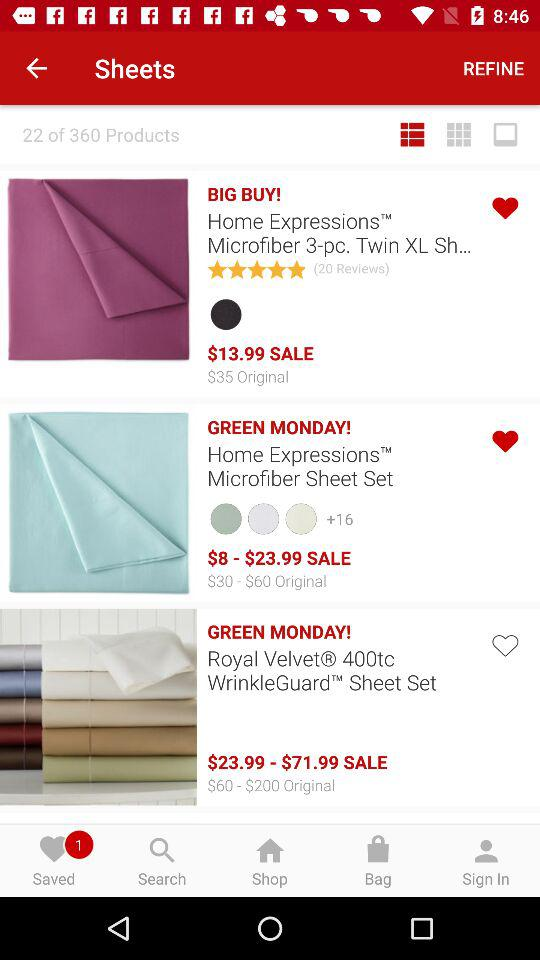What size options are available for the sheet sets on sale? The available sizes for the sheet sets on sale are likely to include standard bedding sizes such as Twin, Twin XL, Full, Queen, King, and California King. Specific availability may vary based on the product line and stock levels. 